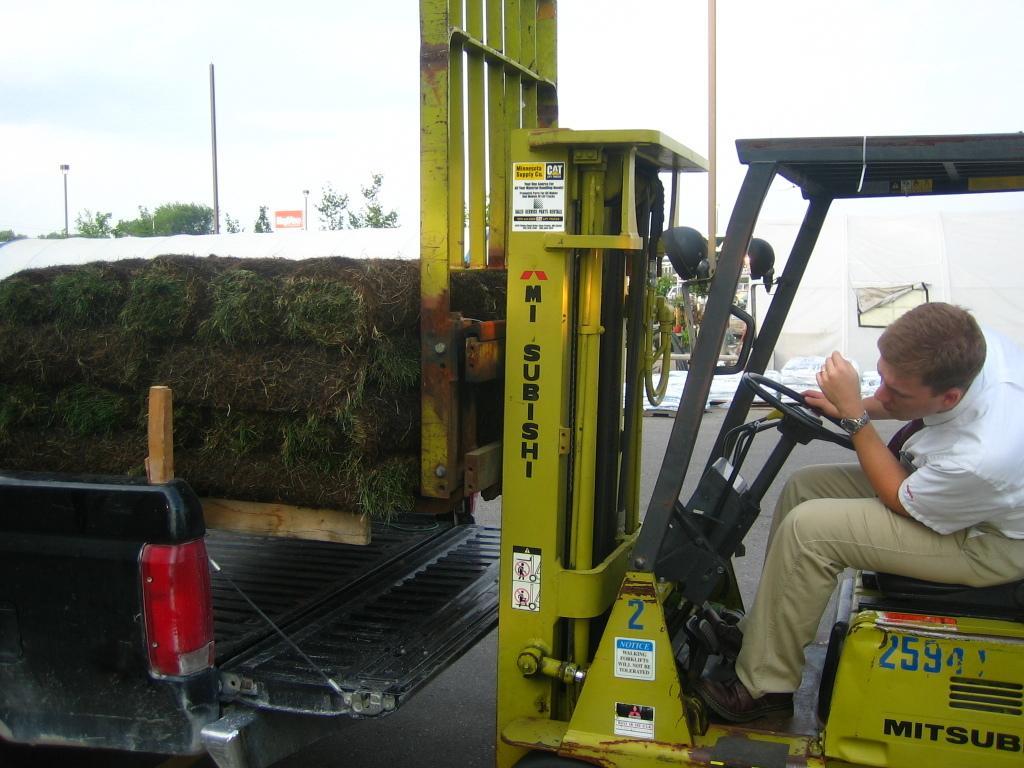Please provide a concise description of this image. In this image I can see the person sitting in the vehicle and the person is wearing white and cream color dress and the vehicle is in green color. Background I can see few plants and trees in green color and I can also see few poles and the sky is in white color. 